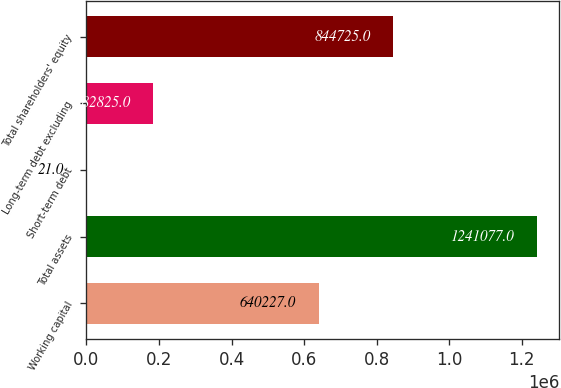<chart> <loc_0><loc_0><loc_500><loc_500><bar_chart><fcel>Working capital<fcel>Total assets<fcel>Short-term debt<fcel>Long-term debt excluding<fcel>Total shareholders' equity<nl><fcel>640227<fcel>1.24108e+06<fcel>21<fcel>182825<fcel>844725<nl></chart> 